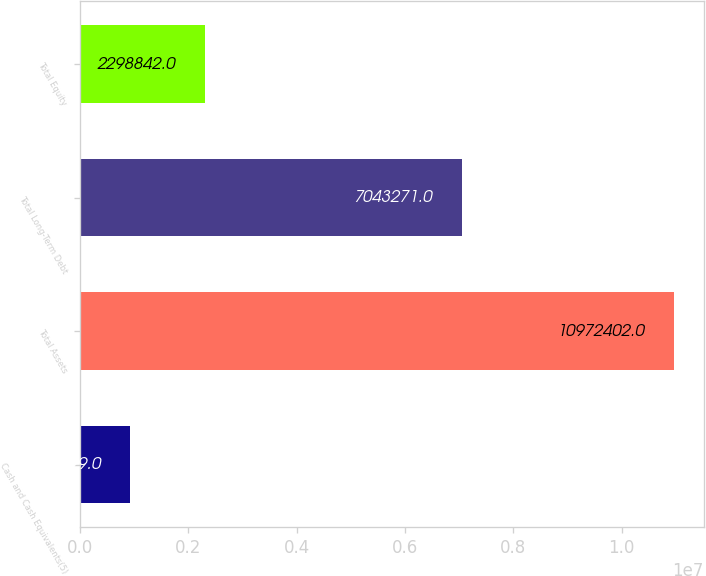Convert chart. <chart><loc_0><loc_0><loc_500><loc_500><bar_chart><fcel>Cash and Cash Equivalents(5)<fcel>Total Assets<fcel>Total Long-Term Debt<fcel>Total Equity<nl><fcel>925699<fcel>1.09724e+07<fcel>7.04327e+06<fcel>2.29884e+06<nl></chart> 